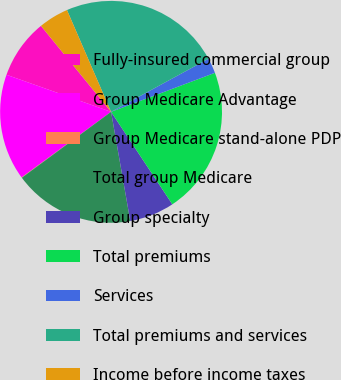Convert chart. <chart><loc_0><loc_0><loc_500><loc_500><pie_chart><fcel>Fully-insured commercial group<fcel>Group Medicare Advantage<fcel>Group Medicare stand-alone PDP<fcel>Total group Medicare<fcel>Group specialty<fcel>Total premiums<fcel>Services<fcel>Total premiums and services<fcel>Income before income taxes<nl><fcel>8.69%<fcel>15.49%<fcel>0.06%<fcel>17.65%<fcel>6.54%<fcel>21.41%<fcel>2.22%<fcel>23.57%<fcel>4.38%<nl></chart> 